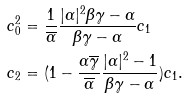<formula> <loc_0><loc_0><loc_500><loc_500>& c _ { 0 } ^ { 2 } = \frac { 1 } { \overline { \alpha } } \frac { | \alpha | ^ { 2 } \beta \gamma - \alpha } { \beta \gamma - \alpha } c _ { 1 } \\ & c _ { 2 } = ( 1 - \frac { \alpha \overline { \gamma } } { \overline { \alpha } } \frac { | \alpha | ^ { 2 } - 1 } { \beta \gamma - \alpha } ) c _ { 1 } .</formula> 